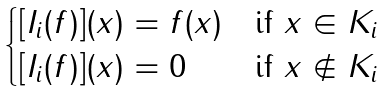<formula> <loc_0><loc_0><loc_500><loc_500>\begin{cases} [ I _ { i } ( f ) ] ( x ) = f ( x ) & \text {if} \ x \in K _ { i } \\ [ I _ { i } ( f ) ] ( x ) = 0 & \text {if} \ x \notin K _ { i } \end{cases}</formula> 